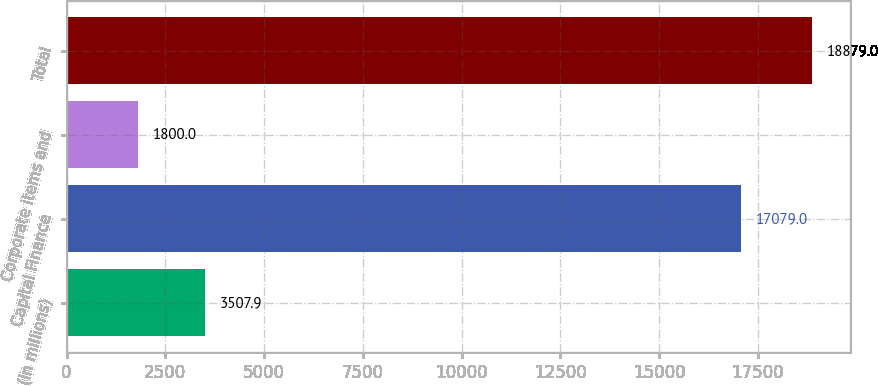Convert chart. <chart><loc_0><loc_0><loc_500><loc_500><bar_chart><fcel>(In millions)<fcel>Capital Finance<fcel>Corporate items and<fcel>Total<nl><fcel>3507.9<fcel>17079<fcel>1800<fcel>18879<nl></chart> 